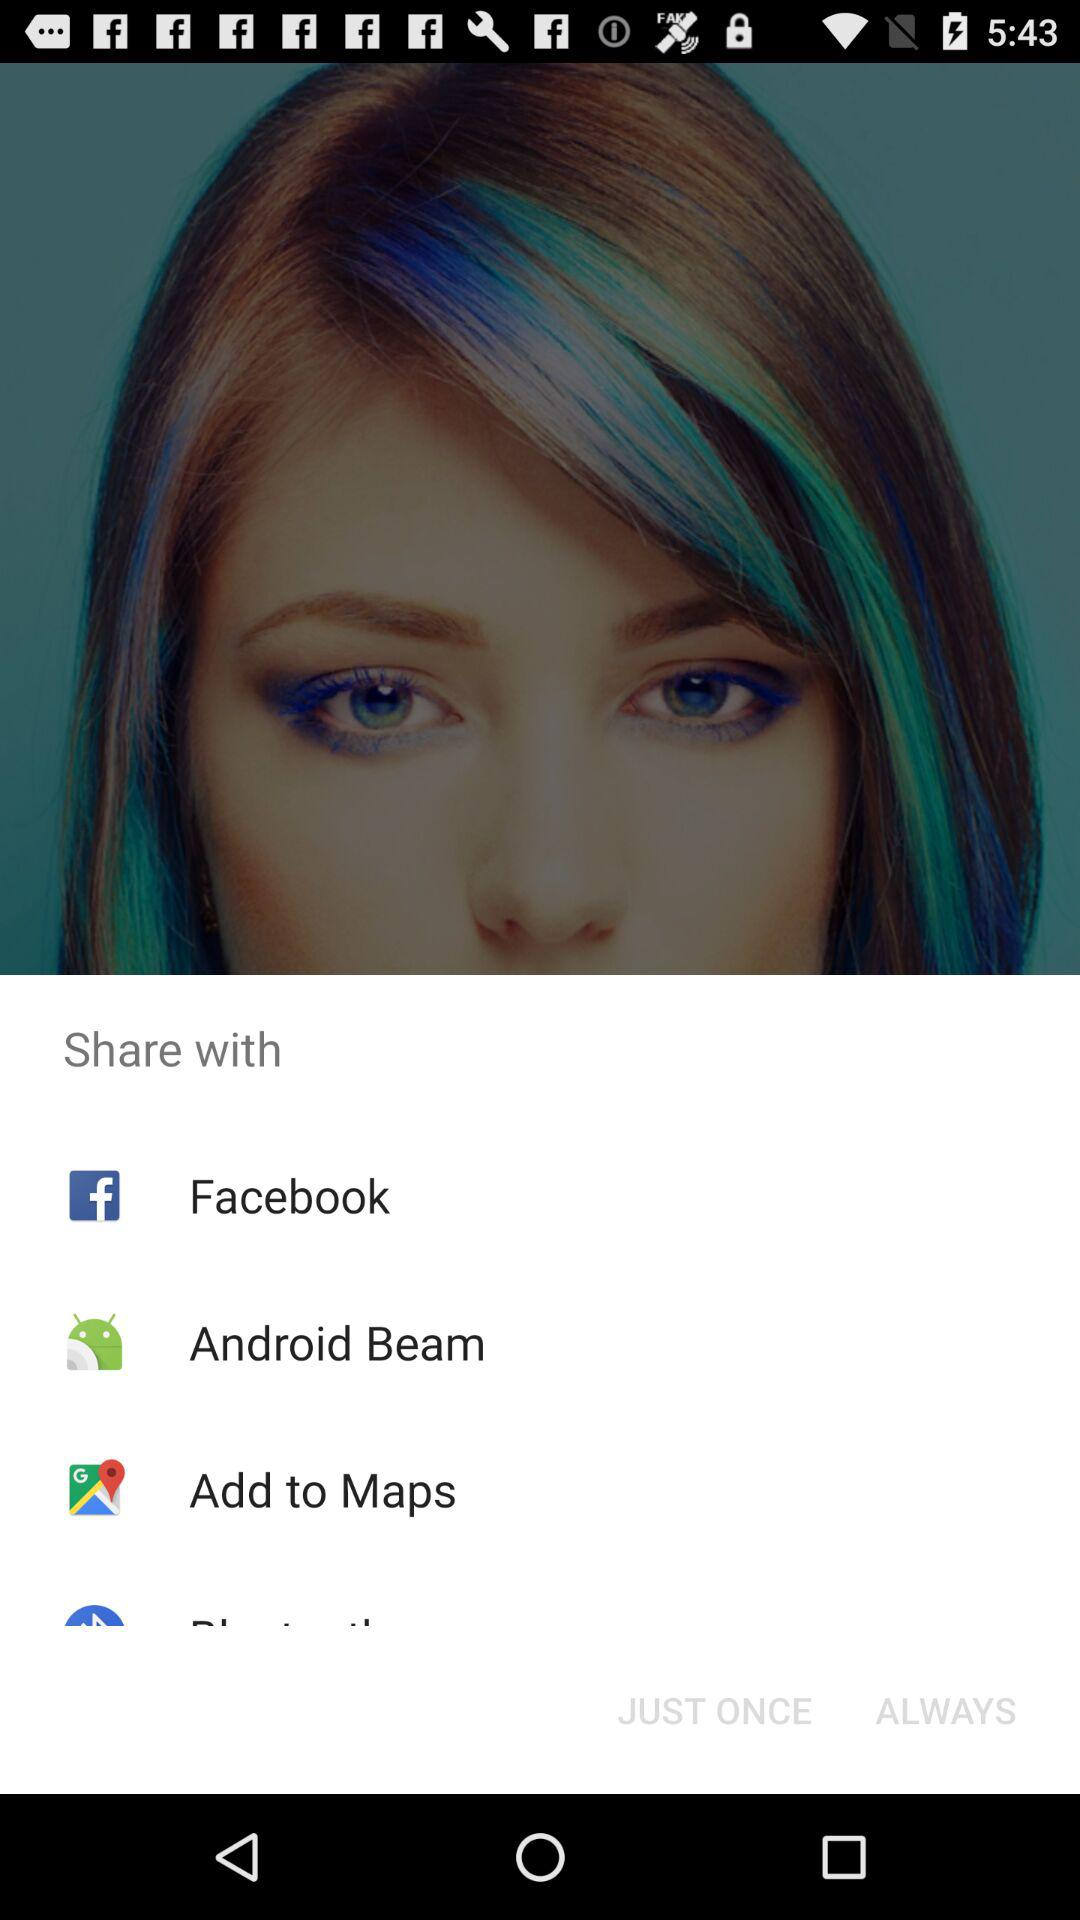How many share options are there?
Answer the question using a single word or phrase. 4 